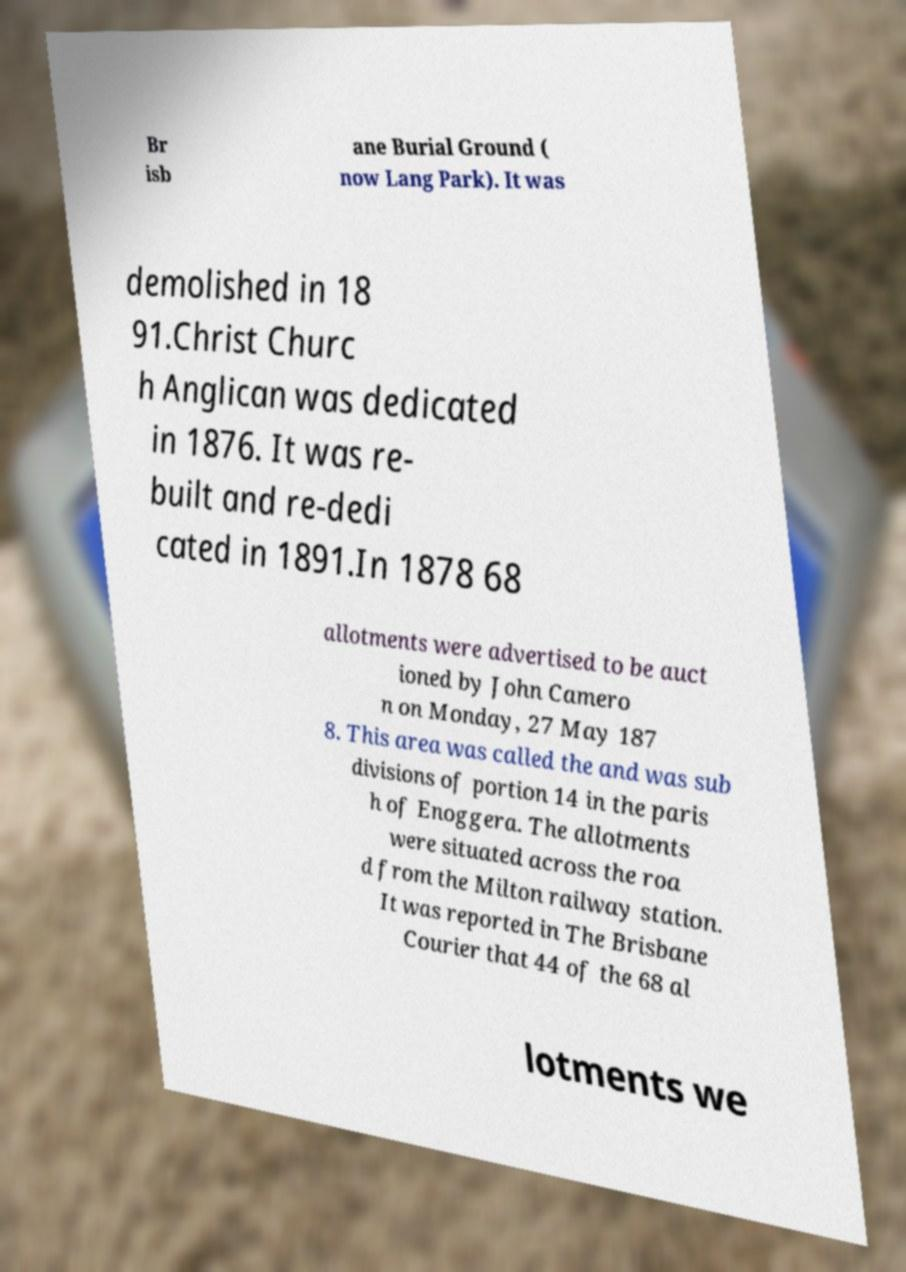What messages or text are displayed in this image? I need them in a readable, typed format. Br isb ane Burial Ground ( now Lang Park). It was demolished in 18 91.Christ Churc h Anglican was dedicated in 1876. It was re- built and re-dedi cated in 1891.In 1878 68 allotments were advertised to be auct ioned by John Camero n on Monday, 27 May 187 8. This area was called the and was sub divisions of portion 14 in the paris h of Enoggera. The allotments were situated across the roa d from the Milton railway station. It was reported in The Brisbane Courier that 44 of the 68 al lotments we 